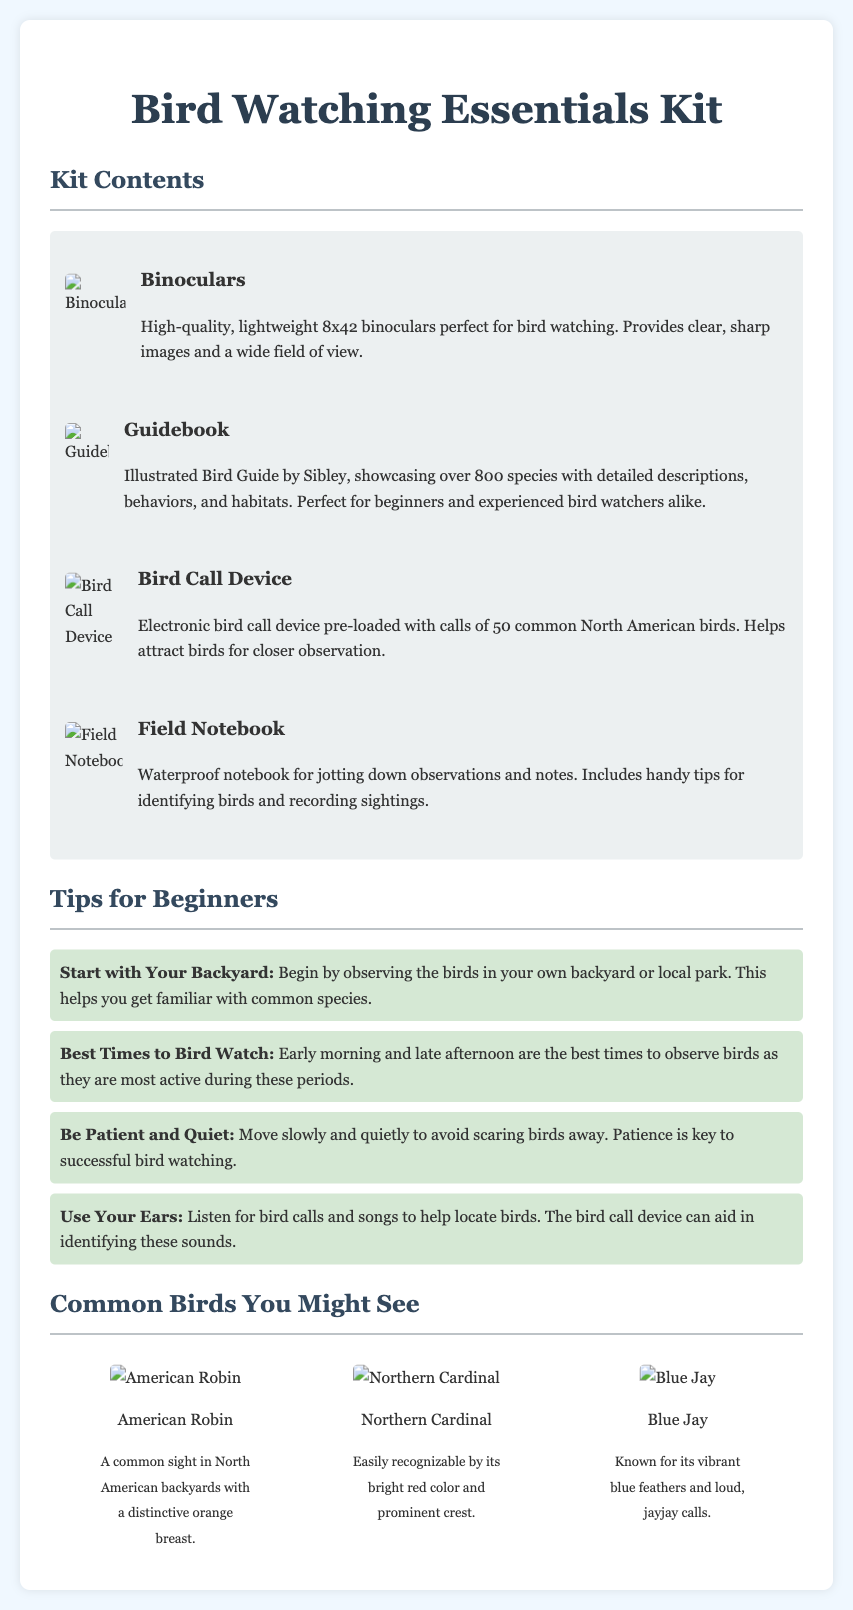what is included in the Bird Watching Essentials Kit? The kit contains binoculars, a guidebook, a bird call device, and a field notebook.
Answer: binoculars, guidebook, bird call device, field notebook how many species does the guidebook showcase? The guidebook showcases over 800 species.
Answer: over 800 species what is the magnification of the binoculars? The binoculars provide an 8x magnification.
Answer: 8x what does the bird call device help with? The bird call device helps attract birds for closer observation.
Answer: attract birds what time of day is best for bird watching? Early morning and late afternoon are the best times.
Answer: Early morning and late afternoon which bird is known for its distinctive orange breast? The American Robin is commonly recognized for its orange breast.
Answer: American Robin how many common North American birds are included in the bird call device? The device is pre-loaded with calls of 50 common North American birds.
Answer: 50 what is a suggested place to start observing birds? Observing the birds in your own backyard is suggested.
Answer: backyard what type of notebook is included in the kit? The kit includes a waterproof notebook.
Answer: waterproof notebook 